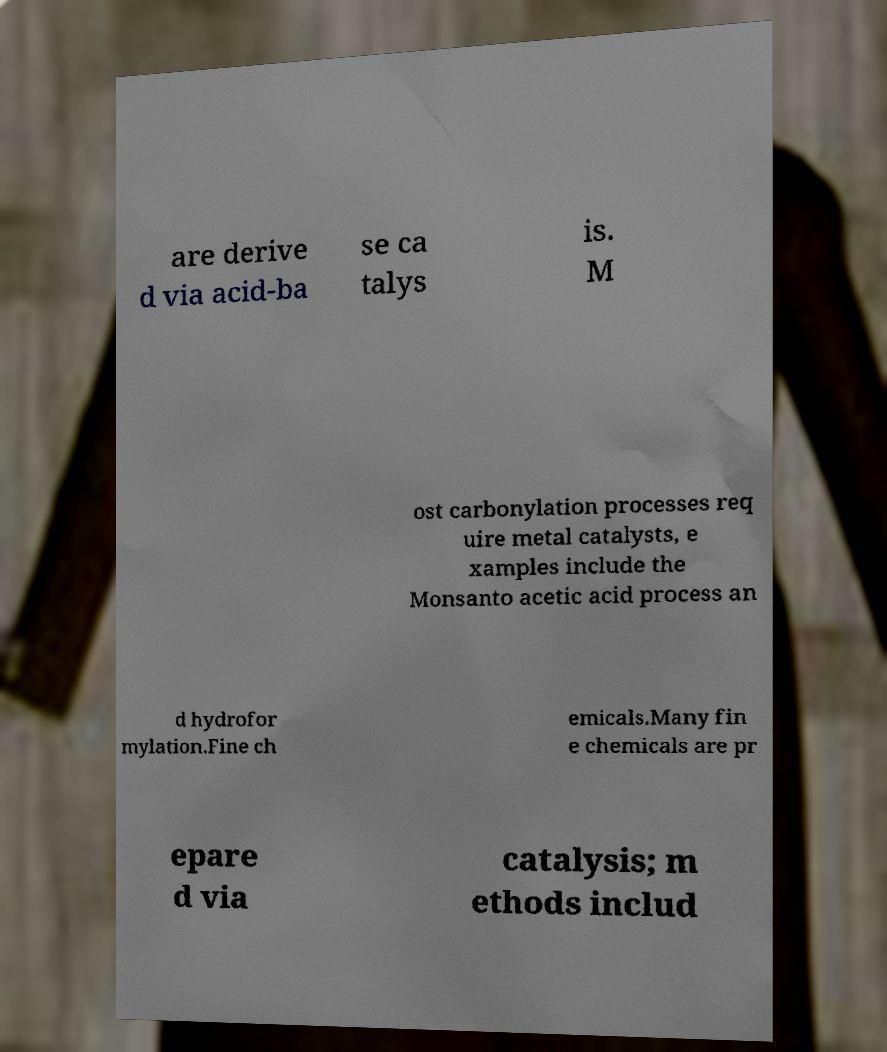What messages or text are displayed in this image? I need them in a readable, typed format. are derive d via acid-ba se ca talys is. M ost carbonylation processes req uire metal catalysts, e xamples include the Monsanto acetic acid process an d hydrofor mylation.Fine ch emicals.Many fin e chemicals are pr epare d via catalysis; m ethods includ 